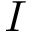<formula> <loc_0><loc_0><loc_500><loc_500>I</formula> 